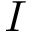<formula> <loc_0><loc_0><loc_500><loc_500>I</formula> 